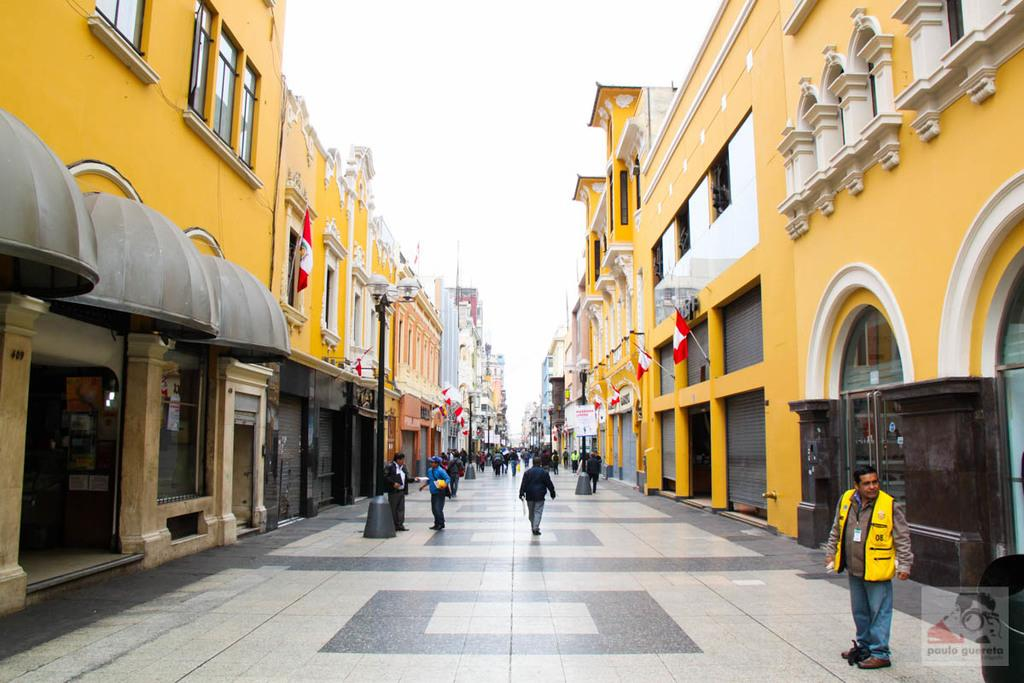What type of structures can be seen in the image? There are buildings in the image. What are the light poles used for in the image? The light poles provide illumination in the image. What do the flags represent in the image? The flags may represent a country, organization, or event in the image. What type of establishments can be found in the image? There are stores in the image. Who or what is present in the image? There are people in the image. What part of the natural environment is visible in the image? The sky is visible in the image. What objects can be seen in the image? There are objects in the image, but their specific nature is not mentioned in the facts. What type of pencil can be seen in the image? There is no pencil present in the image. Is there a tent visible in the image? There is no tent present in the image. 